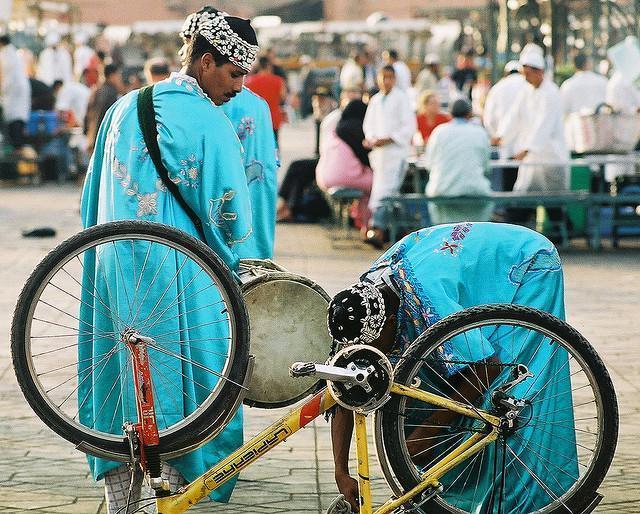How many people are visible?
Give a very brief answer. 6. How many trees to the left of the giraffe are there?
Give a very brief answer. 0. 